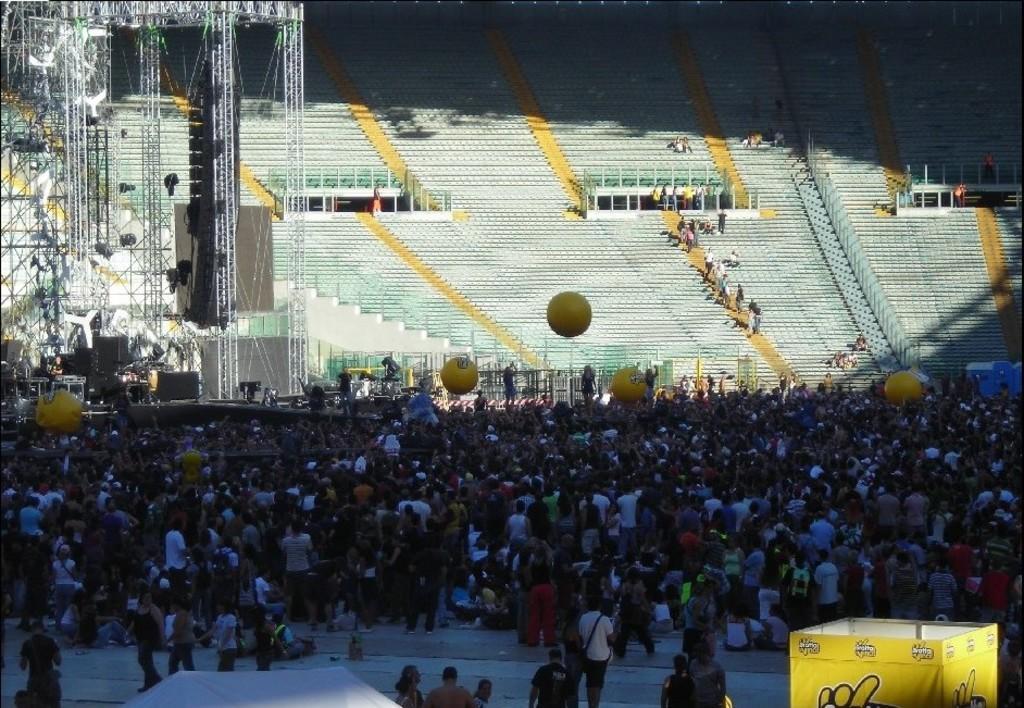How would you summarize this image in a sentence or two? There is a yellow box on the right. Many people are present. There is a stadium at the back and there are wires on the left. 